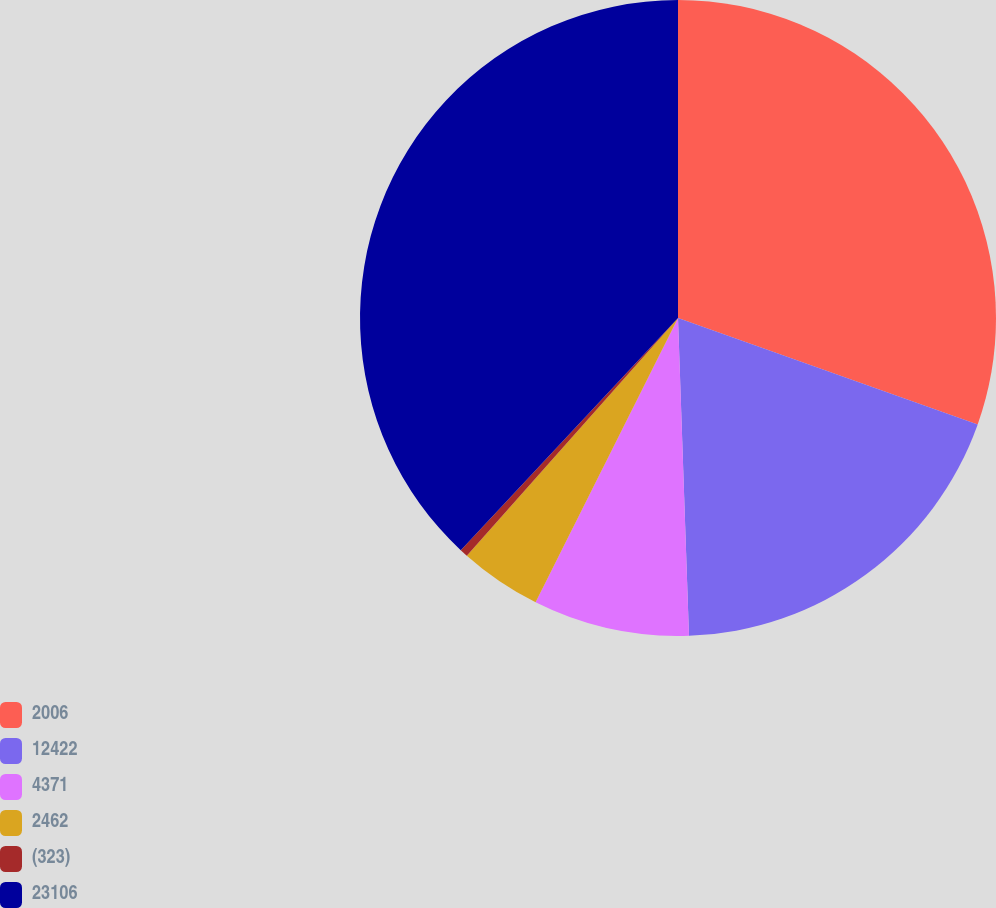Convert chart. <chart><loc_0><loc_0><loc_500><loc_500><pie_chart><fcel>2006<fcel>12422<fcel>4371<fcel>2462<fcel>(323)<fcel>23106<nl><fcel>30.43%<fcel>19.02%<fcel>7.94%<fcel>4.17%<fcel>0.41%<fcel>38.03%<nl></chart> 